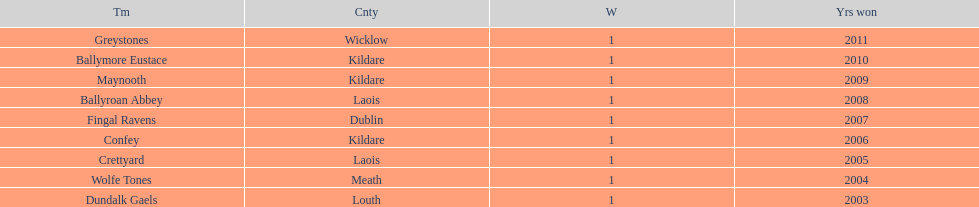How many wins does greystones have? 1. 